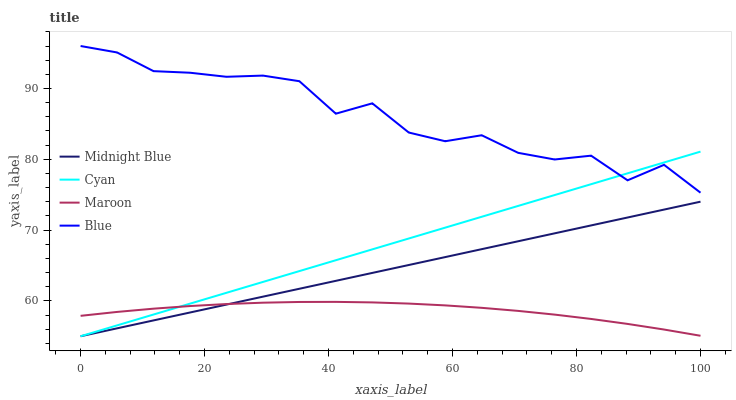Does Maroon have the minimum area under the curve?
Answer yes or no. Yes. Does Blue have the maximum area under the curve?
Answer yes or no. Yes. Does Cyan have the minimum area under the curve?
Answer yes or no. No. Does Cyan have the maximum area under the curve?
Answer yes or no. No. Is Midnight Blue the smoothest?
Answer yes or no. Yes. Is Blue the roughest?
Answer yes or no. Yes. Is Cyan the smoothest?
Answer yes or no. No. Is Cyan the roughest?
Answer yes or no. No. Does Maroon have the lowest value?
Answer yes or no. No. Does Blue have the highest value?
Answer yes or no. Yes. Does Cyan have the highest value?
Answer yes or no. No. Is Maroon less than Blue?
Answer yes or no. Yes. Is Blue greater than Midnight Blue?
Answer yes or no. Yes. Does Maroon intersect Blue?
Answer yes or no. No. 